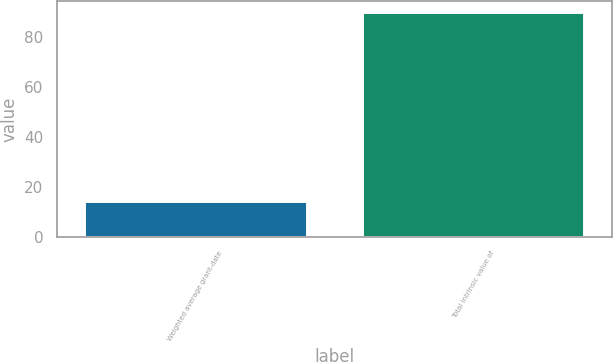<chart> <loc_0><loc_0><loc_500><loc_500><bar_chart><fcel>Weighted average grant-date<fcel>Total intrinsic value of<nl><fcel>14.36<fcel>90<nl></chart> 